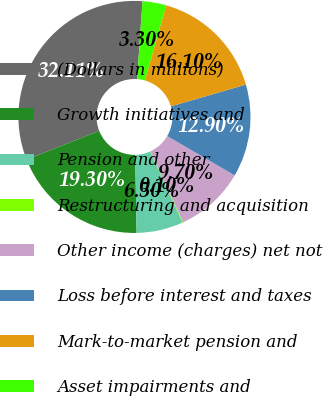Convert chart to OTSL. <chart><loc_0><loc_0><loc_500><loc_500><pie_chart><fcel>(Dollars in millions)<fcel>Growth initiatives and<fcel>Pension and other<fcel>Restructuring and acquisition<fcel>Other income (charges) net not<fcel>Loss before interest and taxes<fcel>Mark-to-market pension and<fcel>Asset impairments and<nl><fcel>32.11%<fcel>19.3%<fcel>6.5%<fcel>0.1%<fcel>9.7%<fcel>12.9%<fcel>16.1%<fcel>3.3%<nl></chart> 